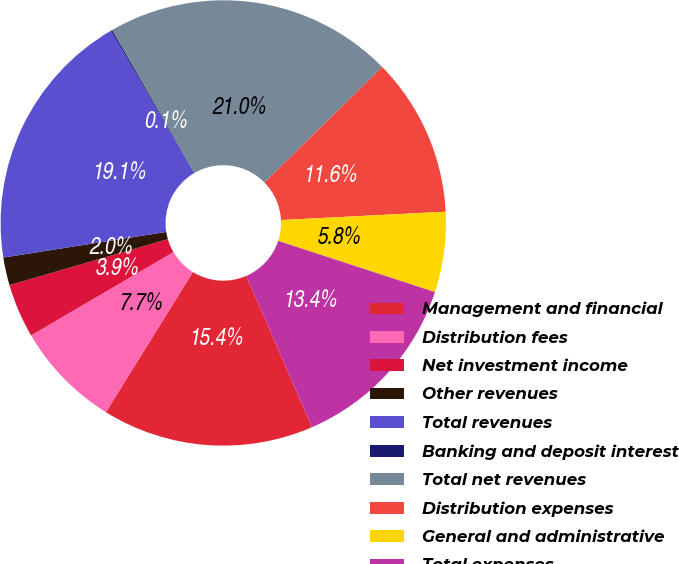<chart> <loc_0><loc_0><loc_500><loc_500><pie_chart><fcel>Management and financial<fcel>Distribution fees<fcel>Net investment income<fcel>Other revenues<fcel>Total revenues<fcel>Banking and deposit interest<fcel>Total net revenues<fcel>Distribution expenses<fcel>General and administrative<fcel>Total expenses<nl><fcel>15.36%<fcel>7.74%<fcel>3.92%<fcel>2.02%<fcel>19.06%<fcel>0.11%<fcel>20.96%<fcel>11.55%<fcel>5.83%<fcel>13.45%<nl></chart> 